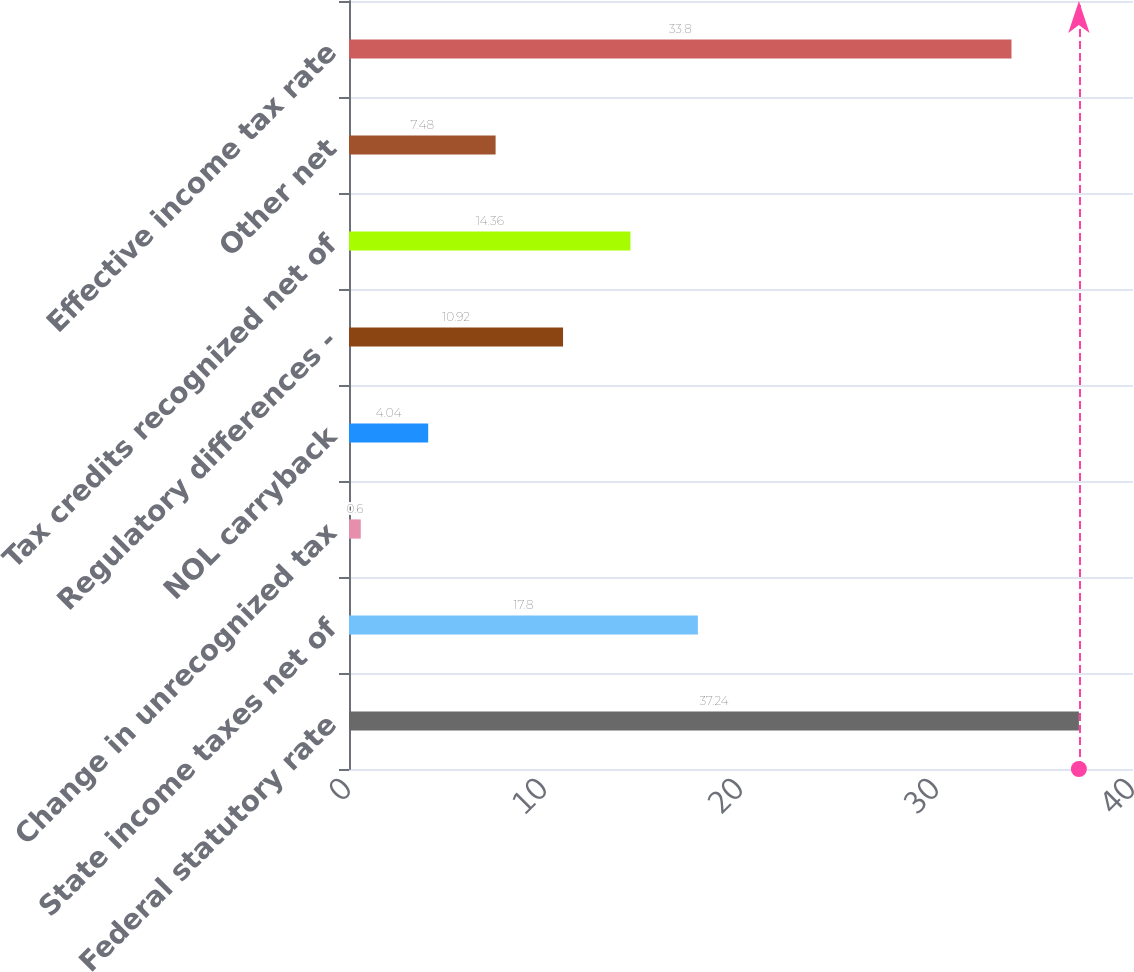Convert chart. <chart><loc_0><loc_0><loc_500><loc_500><bar_chart><fcel>Federal statutory rate<fcel>State income taxes net of<fcel>Change in unrecognized tax<fcel>NOL carryback<fcel>Regulatory differences -<fcel>Tax credits recognized net of<fcel>Other net<fcel>Effective income tax rate<nl><fcel>37.24<fcel>17.8<fcel>0.6<fcel>4.04<fcel>10.92<fcel>14.36<fcel>7.48<fcel>33.8<nl></chart> 